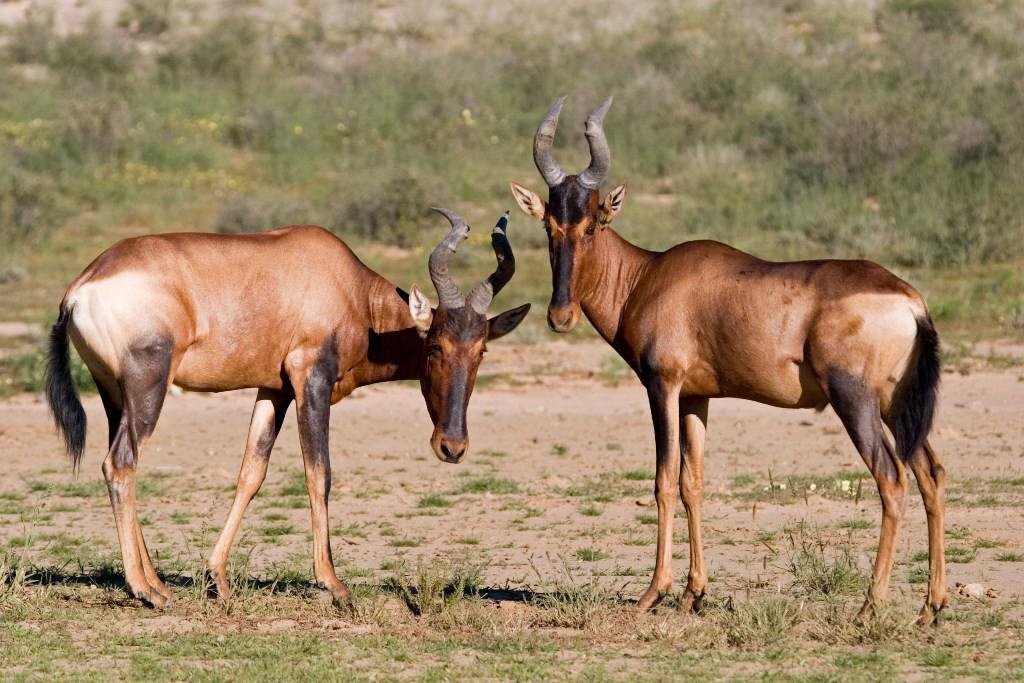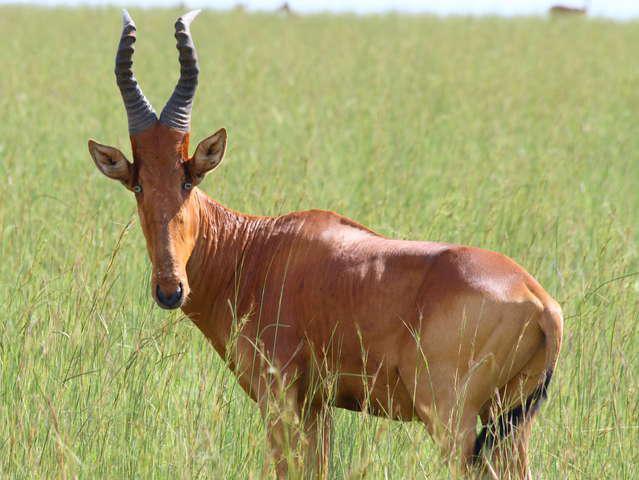The first image is the image on the left, the second image is the image on the right. Examine the images to the left and right. Is the description "There are three gazelle-type creatures standing." accurate? Answer yes or no. Yes. 